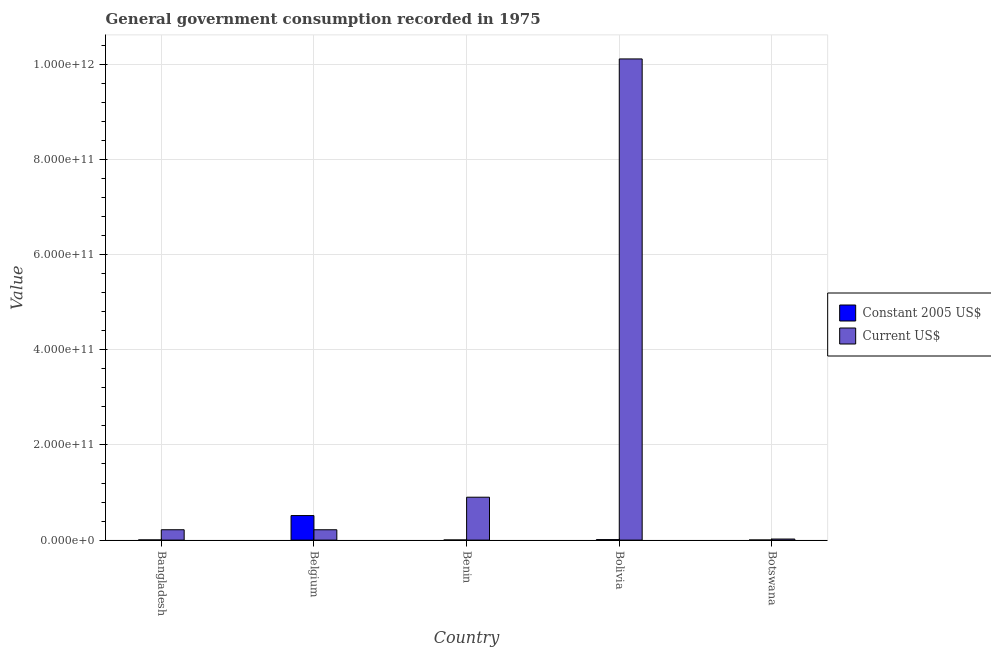How many different coloured bars are there?
Ensure brevity in your answer.  2. What is the value consumed in current us$ in Belgium?
Make the answer very short. 2.17e+1. Across all countries, what is the maximum value consumed in constant 2005 us$?
Offer a very short reply. 5.16e+1. Across all countries, what is the minimum value consumed in current us$?
Your answer should be very brief. 2.23e+09. In which country was the value consumed in current us$ minimum?
Provide a succinct answer. Botswana. What is the total value consumed in current us$ in the graph?
Your response must be concise. 1.15e+12. What is the difference between the value consumed in current us$ in Belgium and that in Benin?
Give a very brief answer. -6.84e+1. What is the difference between the value consumed in current us$ in Bolivia and the value consumed in constant 2005 us$ in Botswana?
Offer a very short reply. 1.01e+12. What is the average value consumed in current us$ per country?
Provide a succinct answer. 2.29e+11. What is the difference between the value consumed in current us$ and value consumed in constant 2005 us$ in Bangladesh?
Make the answer very short. 2.14e+1. In how many countries, is the value consumed in current us$ greater than 960000000000 ?
Offer a very short reply. 1. What is the ratio of the value consumed in constant 2005 us$ in Bangladesh to that in Benin?
Offer a terse response. 1.47. Is the value consumed in constant 2005 us$ in Bangladesh less than that in Bolivia?
Provide a succinct answer. Yes. Is the difference between the value consumed in constant 2005 us$ in Bolivia and Botswana greater than the difference between the value consumed in current us$ in Bolivia and Botswana?
Provide a succinct answer. No. What is the difference between the highest and the second highest value consumed in current us$?
Offer a very short reply. 9.21e+11. What is the difference between the highest and the lowest value consumed in current us$?
Provide a succinct answer. 1.01e+12. In how many countries, is the value consumed in constant 2005 us$ greater than the average value consumed in constant 2005 us$ taken over all countries?
Make the answer very short. 1. Is the sum of the value consumed in constant 2005 us$ in Bangladesh and Benin greater than the maximum value consumed in current us$ across all countries?
Provide a succinct answer. No. What does the 2nd bar from the left in Benin represents?
Make the answer very short. Current US$. What does the 2nd bar from the right in Belgium represents?
Your answer should be very brief. Constant 2005 US$. How many bars are there?
Your response must be concise. 10. How many countries are there in the graph?
Make the answer very short. 5. What is the difference between two consecutive major ticks on the Y-axis?
Your answer should be very brief. 2.00e+11. Does the graph contain any zero values?
Offer a very short reply. No. How many legend labels are there?
Give a very brief answer. 2. How are the legend labels stacked?
Provide a succinct answer. Vertical. What is the title of the graph?
Ensure brevity in your answer.  General government consumption recorded in 1975. What is the label or title of the Y-axis?
Provide a succinct answer. Value. What is the Value in Constant 2005 US$ in Bangladesh?
Keep it short and to the point. 3.40e+08. What is the Value in Current US$ in Bangladesh?
Offer a very short reply. 2.18e+1. What is the Value in Constant 2005 US$ in Belgium?
Provide a succinct answer. 5.16e+1. What is the Value of Current US$ in Belgium?
Your answer should be very brief. 2.17e+1. What is the Value in Constant 2005 US$ in Benin?
Your answer should be compact. 2.31e+08. What is the Value in Current US$ in Benin?
Keep it short and to the point. 9.01e+1. What is the Value of Constant 2005 US$ in Bolivia?
Offer a terse response. 9.85e+08. What is the Value in Current US$ in Bolivia?
Ensure brevity in your answer.  1.01e+12. What is the Value in Constant 2005 US$ in Botswana?
Your response must be concise. 1.70e+08. What is the Value in Current US$ in Botswana?
Keep it short and to the point. 2.23e+09. Across all countries, what is the maximum Value in Constant 2005 US$?
Ensure brevity in your answer.  5.16e+1. Across all countries, what is the maximum Value in Current US$?
Provide a short and direct response. 1.01e+12. Across all countries, what is the minimum Value in Constant 2005 US$?
Make the answer very short. 1.70e+08. Across all countries, what is the minimum Value in Current US$?
Ensure brevity in your answer.  2.23e+09. What is the total Value of Constant 2005 US$ in the graph?
Give a very brief answer. 5.33e+1. What is the total Value of Current US$ in the graph?
Provide a succinct answer. 1.15e+12. What is the difference between the Value in Constant 2005 US$ in Bangladesh and that in Belgium?
Provide a short and direct response. -5.12e+1. What is the difference between the Value in Current US$ in Bangladesh and that in Belgium?
Your answer should be compact. 2.28e+07. What is the difference between the Value of Constant 2005 US$ in Bangladesh and that in Benin?
Offer a very short reply. 1.10e+08. What is the difference between the Value in Current US$ in Bangladesh and that in Benin?
Offer a very short reply. -6.84e+1. What is the difference between the Value of Constant 2005 US$ in Bangladesh and that in Bolivia?
Keep it short and to the point. -6.44e+08. What is the difference between the Value of Current US$ in Bangladesh and that in Bolivia?
Your answer should be compact. -9.90e+11. What is the difference between the Value of Constant 2005 US$ in Bangladesh and that in Botswana?
Keep it short and to the point. 1.70e+08. What is the difference between the Value in Current US$ in Bangladesh and that in Botswana?
Your answer should be compact. 1.95e+1. What is the difference between the Value of Constant 2005 US$ in Belgium and that in Benin?
Your answer should be compact. 5.13e+1. What is the difference between the Value of Current US$ in Belgium and that in Benin?
Give a very brief answer. -6.84e+1. What is the difference between the Value in Constant 2005 US$ in Belgium and that in Bolivia?
Your answer should be compact. 5.06e+1. What is the difference between the Value in Current US$ in Belgium and that in Bolivia?
Make the answer very short. -9.90e+11. What is the difference between the Value of Constant 2005 US$ in Belgium and that in Botswana?
Keep it short and to the point. 5.14e+1. What is the difference between the Value in Current US$ in Belgium and that in Botswana?
Your answer should be compact. 1.95e+1. What is the difference between the Value of Constant 2005 US$ in Benin and that in Bolivia?
Your answer should be compact. -7.54e+08. What is the difference between the Value of Current US$ in Benin and that in Bolivia?
Your answer should be very brief. -9.21e+11. What is the difference between the Value in Constant 2005 US$ in Benin and that in Botswana?
Provide a succinct answer. 6.09e+07. What is the difference between the Value of Current US$ in Benin and that in Botswana?
Your answer should be very brief. 8.79e+1. What is the difference between the Value of Constant 2005 US$ in Bolivia and that in Botswana?
Provide a short and direct response. 8.15e+08. What is the difference between the Value of Current US$ in Bolivia and that in Botswana?
Provide a short and direct response. 1.01e+12. What is the difference between the Value in Constant 2005 US$ in Bangladesh and the Value in Current US$ in Belgium?
Provide a succinct answer. -2.14e+1. What is the difference between the Value in Constant 2005 US$ in Bangladesh and the Value in Current US$ in Benin?
Your answer should be very brief. -8.98e+1. What is the difference between the Value of Constant 2005 US$ in Bangladesh and the Value of Current US$ in Bolivia?
Your answer should be compact. -1.01e+12. What is the difference between the Value of Constant 2005 US$ in Bangladesh and the Value of Current US$ in Botswana?
Give a very brief answer. -1.89e+09. What is the difference between the Value of Constant 2005 US$ in Belgium and the Value of Current US$ in Benin?
Your answer should be very brief. -3.86e+1. What is the difference between the Value in Constant 2005 US$ in Belgium and the Value in Current US$ in Bolivia?
Give a very brief answer. -9.60e+11. What is the difference between the Value in Constant 2005 US$ in Belgium and the Value in Current US$ in Botswana?
Give a very brief answer. 4.93e+1. What is the difference between the Value in Constant 2005 US$ in Benin and the Value in Current US$ in Bolivia?
Give a very brief answer. -1.01e+12. What is the difference between the Value in Constant 2005 US$ in Benin and the Value in Current US$ in Botswana?
Provide a short and direct response. -2.00e+09. What is the difference between the Value of Constant 2005 US$ in Bolivia and the Value of Current US$ in Botswana?
Give a very brief answer. -1.25e+09. What is the average Value of Constant 2005 US$ per country?
Your answer should be compact. 1.07e+1. What is the average Value of Current US$ per country?
Give a very brief answer. 2.29e+11. What is the difference between the Value of Constant 2005 US$ and Value of Current US$ in Bangladesh?
Offer a terse response. -2.14e+1. What is the difference between the Value of Constant 2005 US$ and Value of Current US$ in Belgium?
Ensure brevity in your answer.  2.98e+1. What is the difference between the Value in Constant 2005 US$ and Value in Current US$ in Benin?
Ensure brevity in your answer.  -8.99e+1. What is the difference between the Value of Constant 2005 US$ and Value of Current US$ in Bolivia?
Your response must be concise. -1.01e+12. What is the difference between the Value of Constant 2005 US$ and Value of Current US$ in Botswana?
Provide a short and direct response. -2.06e+09. What is the ratio of the Value in Constant 2005 US$ in Bangladesh to that in Belgium?
Offer a very short reply. 0.01. What is the ratio of the Value in Current US$ in Bangladesh to that in Belgium?
Provide a short and direct response. 1. What is the ratio of the Value in Constant 2005 US$ in Bangladesh to that in Benin?
Make the answer very short. 1.47. What is the ratio of the Value of Current US$ in Bangladesh to that in Benin?
Provide a short and direct response. 0.24. What is the ratio of the Value in Constant 2005 US$ in Bangladesh to that in Bolivia?
Provide a succinct answer. 0.35. What is the ratio of the Value of Current US$ in Bangladesh to that in Bolivia?
Your answer should be very brief. 0.02. What is the ratio of the Value of Constant 2005 US$ in Bangladesh to that in Botswana?
Your answer should be very brief. 2. What is the ratio of the Value of Current US$ in Bangladesh to that in Botswana?
Your answer should be very brief. 9.74. What is the ratio of the Value in Constant 2005 US$ in Belgium to that in Benin?
Your response must be concise. 223.37. What is the ratio of the Value of Current US$ in Belgium to that in Benin?
Offer a very short reply. 0.24. What is the ratio of the Value in Constant 2005 US$ in Belgium to that in Bolivia?
Provide a succinct answer. 52.38. What is the ratio of the Value of Current US$ in Belgium to that in Bolivia?
Offer a very short reply. 0.02. What is the ratio of the Value in Constant 2005 US$ in Belgium to that in Botswana?
Offer a very short reply. 303.43. What is the ratio of the Value of Current US$ in Belgium to that in Botswana?
Your response must be concise. 9.73. What is the ratio of the Value in Constant 2005 US$ in Benin to that in Bolivia?
Your answer should be compact. 0.23. What is the ratio of the Value in Current US$ in Benin to that in Bolivia?
Your response must be concise. 0.09. What is the ratio of the Value in Constant 2005 US$ in Benin to that in Botswana?
Keep it short and to the point. 1.36. What is the ratio of the Value in Current US$ in Benin to that in Botswana?
Offer a very short reply. 40.36. What is the ratio of the Value in Constant 2005 US$ in Bolivia to that in Botswana?
Give a very brief answer. 5.79. What is the ratio of the Value of Current US$ in Bolivia to that in Botswana?
Give a very brief answer. 452.79. What is the difference between the highest and the second highest Value of Constant 2005 US$?
Ensure brevity in your answer.  5.06e+1. What is the difference between the highest and the second highest Value in Current US$?
Keep it short and to the point. 9.21e+11. What is the difference between the highest and the lowest Value of Constant 2005 US$?
Make the answer very short. 5.14e+1. What is the difference between the highest and the lowest Value of Current US$?
Provide a succinct answer. 1.01e+12. 